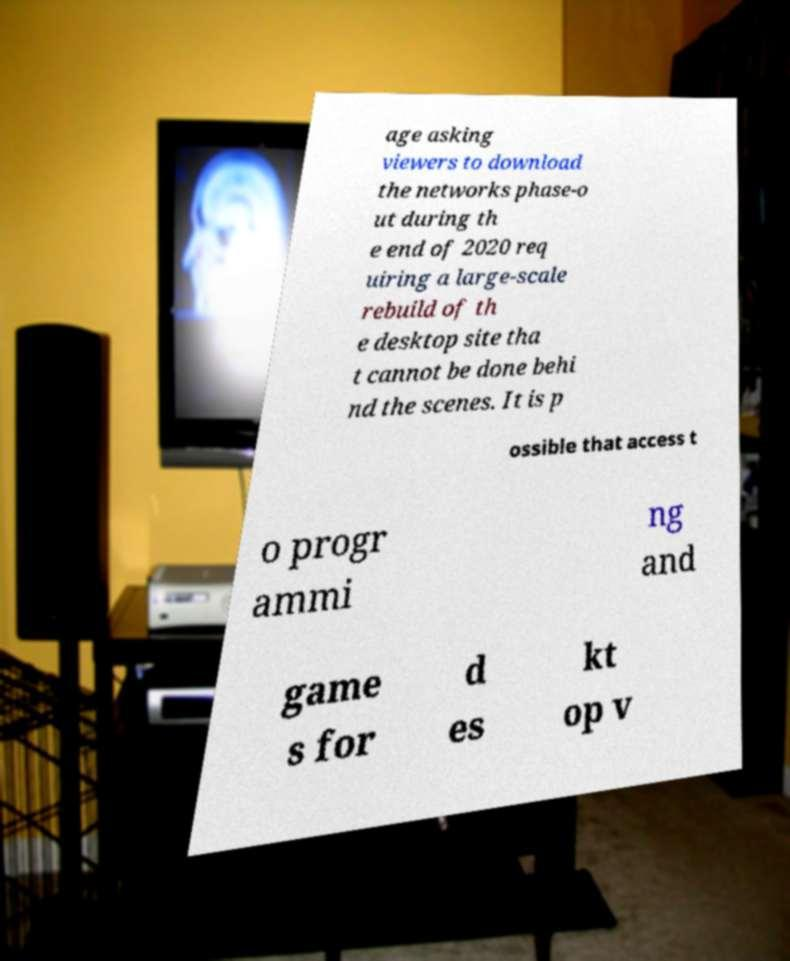What messages or text are displayed in this image? I need them in a readable, typed format. age asking viewers to download the networks phase-o ut during th e end of 2020 req uiring a large-scale rebuild of th e desktop site tha t cannot be done behi nd the scenes. It is p ossible that access t o progr ammi ng and game s for d es kt op v 